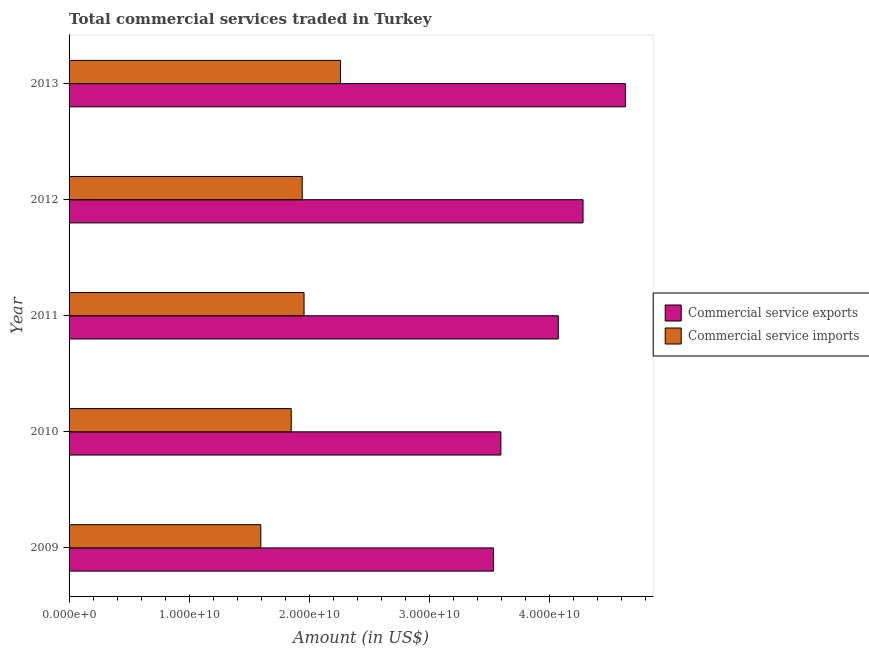How many different coloured bars are there?
Give a very brief answer. 2. How many groups of bars are there?
Provide a short and direct response. 5. Are the number of bars on each tick of the Y-axis equal?
Make the answer very short. Yes. How many bars are there on the 4th tick from the top?
Provide a succinct answer. 2. How many bars are there on the 1st tick from the bottom?
Ensure brevity in your answer.  2. What is the amount of commercial service imports in 2013?
Provide a succinct answer. 2.26e+1. Across all years, what is the maximum amount of commercial service exports?
Provide a short and direct response. 4.63e+1. Across all years, what is the minimum amount of commercial service exports?
Ensure brevity in your answer.  3.54e+1. What is the total amount of commercial service exports in the graph?
Give a very brief answer. 2.01e+11. What is the difference between the amount of commercial service exports in 2011 and that in 2013?
Your response must be concise. -5.59e+09. What is the difference between the amount of commercial service exports in 2009 and the amount of commercial service imports in 2010?
Offer a terse response. 1.68e+1. What is the average amount of commercial service exports per year?
Provide a short and direct response. 4.02e+1. In the year 2011, what is the difference between the amount of commercial service exports and amount of commercial service imports?
Give a very brief answer. 2.12e+1. In how many years, is the amount of commercial service exports greater than 20000000000 US$?
Ensure brevity in your answer.  5. What is the ratio of the amount of commercial service imports in 2010 to that in 2011?
Provide a short and direct response. 0.94. Is the difference between the amount of commercial service exports in 2009 and 2010 greater than the difference between the amount of commercial service imports in 2009 and 2010?
Make the answer very short. Yes. What is the difference between the highest and the second highest amount of commercial service exports?
Your answer should be compact. 3.53e+09. What is the difference between the highest and the lowest amount of commercial service imports?
Make the answer very short. 6.64e+09. What does the 1st bar from the top in 2013 represents?
Provide a short and direct response. Commercial service imports. What does the 1st bar from the bottom in 2013 represents?
Offer a very short reply. Commercial service exports. How many bars are there?
Give a very brief answer. 10. What is the difference between two consecutive major ticks on the X-axis?
Offer a terse response. 1.00e+1. Are the values on the major ticks of X-axis written in scientific E-notation?
Your answer should be very brief. Yes. Does the graph contain grids?
Provide a short and direct response. No. How are the legend labels stacked?
Provide a succinct answer. Vertical. What is the title of the graph?
Offer a very short reply. Total commercial services traded in Turkey. What is the label or title of the X-axis?
Offer a terse response. Amount (in US$). What is the Amount (in US$) of Commercial service exports in 2009?
Make the answer very short. 3.54e+1. What is the Amount (in US$) in Commercial service imports in 2009?
Keep it short and to the point. 1.60e+1. What is the Amount (in US$) in Commercial service exports in 2010?
Keep it short and to the point. 3.60e+1. What is the Amount (in US$) of Commercial service imports in 2010?
Your answer should be compact. 1.85e+1. What is the Amount (in US$) in Commercial service exports in 2011?
Offer a terse response. 4.08e+1. What is the Amount (in US$) of Commercial service imports in 2011?
Keep it short and to the point. 1.96e+1. What is the Amount (in US$) of Commercial service exports in 2012?
Keep it short and to the point. 4.28e+1. What is the Amount (in US$) in Commercial service imports in 2012?
Keep it short and to the point. 1.94e+1. What is the Amount (in US$) in Commercial service exports in 2013?
Offer a terse response. 4.63e+1. What is the Amount (in US$) of Commercial service imports in 2013?
Your response must be concise. 2.26e+1. Across all years, what is the maximum Amount (in US$) of Commercial service exports?
Keep it short and to the point. 4.63e+1. Across all years, what is the maximum Amount (in US$) of Commercial service imports?
Your answer should be very brief. 2.26e+1. Across all years, what is the minimum Amount (in US$) in Commercial service exports?
Ensure brevity in your answer.  3.54e+1. Across all years, what is the minimum Amount (in US$) of Commercial service imports?
Offer a terse response. 1.60e+1. What is the total Amount (in US$) in Commercial service exports in the graph?
Provide a short and direct response. 2.01e+11. What is the total Amount (in US$) in Commercial service imports in the graph?
Your answer should be compact. 9.61e+1. What is the difference between the Amount (in US$) in Commercial service exports in 2009 and that in 2010?
Your response must be concise. -6.15e+08. What is the difference between the Amount (in US$) of Commercial service imports in 2009 and that in 2010?
Provide a short and direct response. -2.54e+09. What is the difference between the Amount (in US$) of Commercial service exports in 2009 and that in 2011?
Offer a very short reply. -5.40e+09. What is the difference between the Amount (in US$) in Commercial service imports in 2009 and that in 2011?
Make the answer very short. -3.60e+09. What is the difference between the Amount (in US$) of Commercial service exports in 2009 and that in 2012?
Keep it short and to the point. -7.46e+09. What is the difference between the Amount (in US$) in Commercial service imports in 2009 and that in 2012?
Give a very brief answer. -3.45e+09. What is the difference between the Amount (in US$) in Commercial service exports in 2009 and that in 2013?
Give a very brief answer. -1.10e+1. What is the difference between the Amount (in US$) in Commercial service imports in 2009 and that in 2013?
Provide a succinct answer. -6.64e+09. What is the difference between the Amount (in US$) of Commercial service exports in 2010 and that in 2011?
Keep it short and to the point. -4.78e+09. What is the difference between the Amount (in US$) of Commercial service imports in 2010 and that in 2011?
Give a very brief answer. -1.07e+09. What is the difference between the Amount (in US$) of Commercial service exports in 2010 and that in 2012?
Your answer should be compact. -6.84e+09. What is the difference between the Amount (in US$) in Commercial service imports in 2010 and that in 2012?
Make the answer very short. -9.15e+08. What is the difference between the Amount (in US$) in Commercial service exports in 2010 and that in 2013?
Ensure brevity in your answer.  -1.04e+1. What is the difference between the Amount (in US$) in Commercial service imports in 2010 and that in 2013?
Your answer should be very brief. -4.10e+09. What is the difference between the Amount (in US$) of Commercial service exports in 2011 and that in 2012?
Provide a short and direct response. -2.06e+09. What is the difference between the Amount (in US$) in Commercial service imports in 2011 and that in 2012?
Provide a short and direct response. 1.52e+08. What is the difference between the Amount (in US$) in Commercial service exports in 2011 and that in 2013?
Your answer should be compact. -5.59e+09. What is the difference between the Amount (in US$) in Commercial service imports in 2011 and that in 2013?
Offer a very short reply. -3.04e+09. What is the difference between the Amount (in US$) of Commercial service exports in 2012 and that in 2013?
Offer a terse response. -3.53e+09. What is the difference between the Amount (in US$) of Commercial service imports in 2012 and that in 2013?
Provide a short and direct response. -3.19e+09. What is the difference between the Amount (in US$) of Commercial service exports in 2009 and the Amount (in US$) of Commercial service imports in 2010?
Make the answer very short. 1.68e+1. What is the difference between the Amount (in US$) of Commercial service exports in 2009 and the Amount (in US$) of Commercial service imports in 2011?
Your response must be concise. 1.58e+1. What is the difference between the Amount (in US$) in Commercial service exports in 2009 and the Amount (in US$) in Commercial service imports in 2012?
Keep it short and to the point. 1.59e+1. What is the difference between the Amount (in US$) of Commercial service exports in 2009 and the Amount (in US$) of Commercial service imports in 2013?
Offer a terse response. 1.27e+1. What is the difference between the Amount (in US$) in Commercial service exports in 2010 and the Amount (in US$) in Commercial service imports in 2011?
Offer a very short reply. 1.64e+1. What is the difference between the Amount (in US$) in Commercial service exports in 2010 and the Amount (in US$) in Commercial service imports in 2012?
Make the answer very short. 1.65e+1. What is the difference between the Amount (in US$) in Commercial service exports in 2010 and the Amount (in US$) in Commercial service imports in 2013?
Make the answer very short. 1.34e+1. What is the difference between the Amount (in US$) of Commercial service exports in 2011 and the Amount (in US$) of Commercial service imports in 2012?
Ensure brevity in your answer.  2.13e+1. What is the difference between the Amount (in US$) in Commercial service exports in 2011 and the Amount (in US$) in Commercial service imports in 2013?
Ensure brevity in your answer.  1.81e+1. What is the difference between the Amount (in US$) of Commercial service exports in 2012 and the Amount (in US$) of Commercial service imports in 2013?
Ensure brevity in your answer.  2.02e+1. What is the average Amount (in US$) of Commercial service exports per year?
Your answer should be very brief. 4.02e+1. What is the average Amount (in US$) of Commercial service imports per year?
Your answer should be very brief. 1.92e+1. In the year 2009, what is the difference between the Amount (in US$) of Commercial service exports and Amount (in US$) of Commercial service imports?
Your response must be concise. 1.94e+1. In the year 2010, what is the difference between the Amount (in US$) in Commercial service exports and Amount (in US$) in Commercial service imports?
Provide a succinct answer. 1.75e+1. In the year 2011, what is the difference between the Amount (in US$) in Commercial service exports and Amount (in US$) in Commercial service imports?
Keep it short and to the point. 2.12e+1. In the year 2012, what is the difference between the Amount (in US$) in Commercial service exports and Amount (in US$) in Commercial service imports?
Offer a terse response. 2.34e+1. In the year 2013, what is the difference between the Amount (in US$) in Commercial service exports and Amount (in US$) in Commercial service imports?
Provide a short and direct response. 2.37e+1. What is the ratio of the Amount (in US$) in Commercial service exports in 2009 to that in 2010?
Make the answer very short. 0.98. What is the ratio of the Amount (in US$) of Commercial service imports in 2009 to that in 2010?
Offer a terse response. 0.86. What is the ratio of the Amount (in US$) in Commercial service exports in 2009 to that in 2011?
Offer a terse response. 0.87. What is the ratio of the Amount (in US$) of Commercial service imports in 2009 to that in 2011?
Keep it short and to the point. 0.82. What is the ratio of the Amount (in US$) in Commercial service exports in 2009 to that in 2012?
Provide a succinct answer. 0.83. What is the ratio of the Amount (in US$) of Commercial service imports in 2009 to that in 2012?
Provide a succinct answer. 0.82. What is the ratio of the Amount (in US$) in Commercial service exports in 2009 to that in 2013?
Give a very brief answer. 0.76. What is the ratio of the Amount (in US$) in Commercial service imports in 2009 to that in 2013?
Your response must be concise. 0.71. What is the ratio of the Amount (in US$) in Commercial service exports in 2010 to that in 2011?
Your response must be concise. 0.88. What is the ratio of the Amount (in US$) in Commercial service imports in 2010 to that in 2011?
Keep it short and to the point. 0.95. What is the ratio of the Amount (in US$) of Commercial service exports in 2010 to that in 2012?
Offer a very short reply. 0.84. What is the ratio of the Amount (in US$) of Commercial service imports in 2010 to that in 2012?
Your response must be concise. 0.95. What is the ratio of the Amount (in US$) of Commercial service exports in 2010 to that in 2013?
Your response must be concise. 0.78. What is the ratio of the Amount (in US$) in Commercial service imports in 2010 to that in 2013?
Offer a very short reply. 0.82. What is the ratio of the Amount (in US$) in Commercial service exports in 2011 to that in 2012?
Your answer should be very brief. 0.95. What is the ratio of the Amount (in US$) in Commercial service exports in 2011 to that in 2013?
Provide a succinct answer. 0.88. What is the ratio of the Amount (in US$) of Commercial service imports in 2011 to that in 2013?
Keep it short and to the point. 0.87. What is the ratio of the Amount (in US$) in Commercial service exports in 2012 to that in 2013?
Your answer should be very brief. 0.92. What is the ratio of the Amount (in US$) of Commercial service imports in 2012 to that in 2013?
Keep it short and to the point. 0.86. What is the difference between the highest and the second highest Amount (in US$) of Commercial service exports?
Offer a terse response. 3.53e+09. What is the difference between the highest and the second highest Amount (in US$) of Commercial service imports?
Your answer should be very brief. 3.04e+09. What is the difference between the highest and the lowest Amount (in US$) of Commercial service exports?
Your answer should be very brief. 1.10e+1. What is the difference between the highest and the lowest Amount (in US$) of Commercial service imports?
Your answer should be compact. 6.64e+09. 